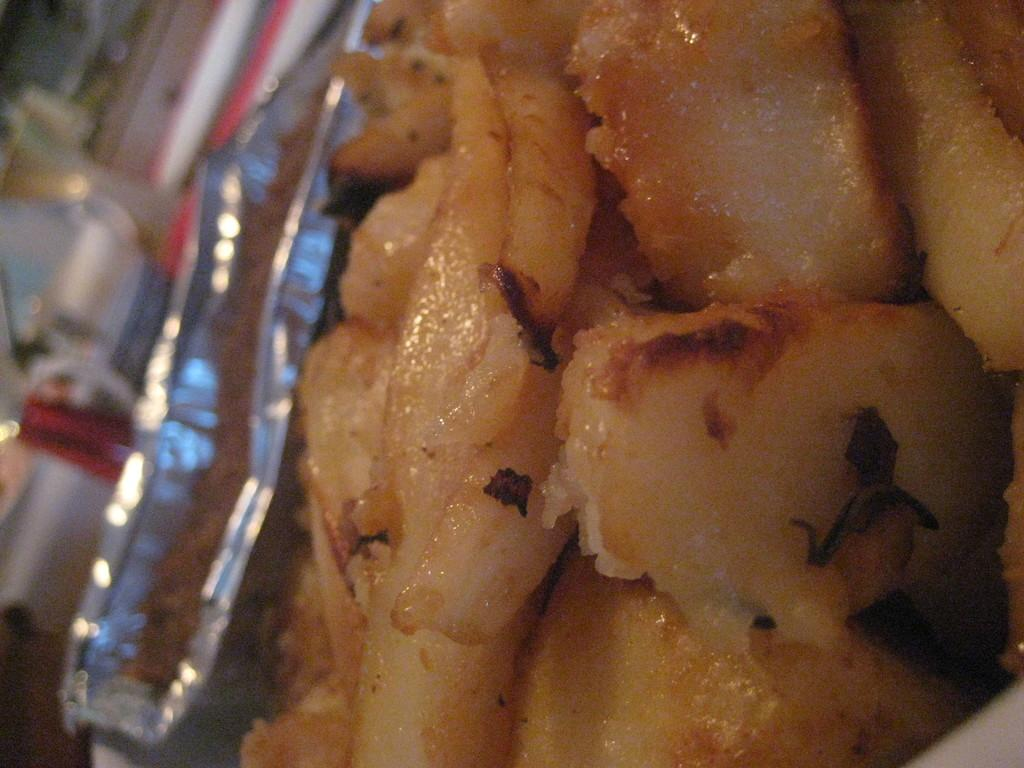What object can be seen in the image? There is a box in the image. What is inside the box? The box contains eatables. What type of force is being applied to the box in the image? There is no indication of any force being applied to the box in the image. 